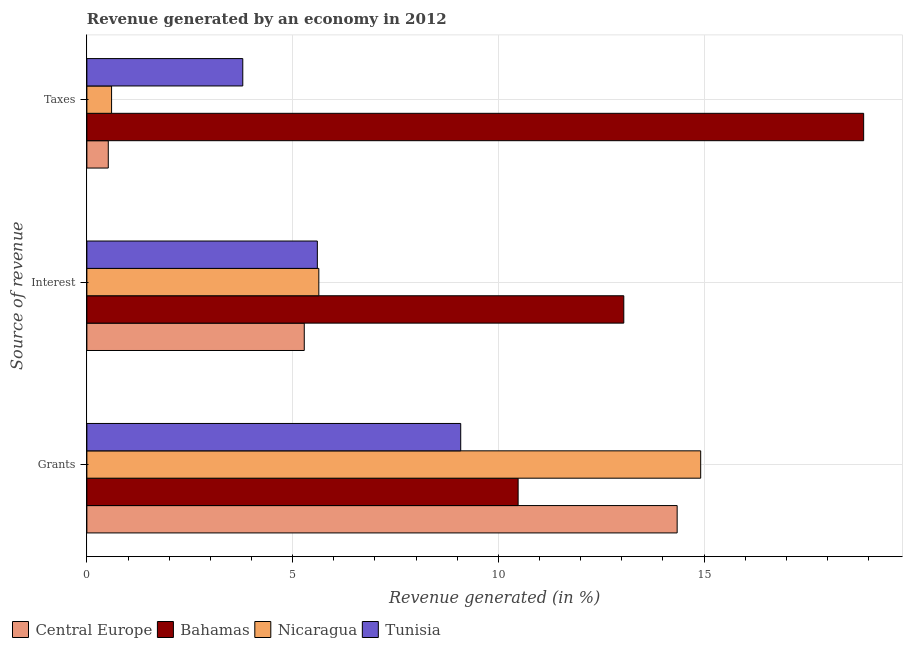How many different coloured bars are there?
Provide a short and direct response. 4. How many groups of bars are there?
Your answer should be very brief. 3. Are the number of bars per tick equal to the number of legend labels?
Offer a very short reply. Yes. How many bars are there on the 3rd tick from the bottom?
Ensure brevity in your answer.  4. What is the label of the 3rd group of bars from the top?
Provide a succinct answer. Grants. What is the percentage of revenue generated by taxes in Bahamas?
Ensure brevity in your answer.  18.88. Across all countries, what is the maximum percentage of revenue generated by grants?
Provide a succinct answer. 14.92. Across all countries, what is the minimum percentage of revenue generated by interest?
Ensure brevity in your answer.  5.28. In which country was the percentage of revenue generated by taxes maximum?
Give a very brief answer. Bahamas. In which country was the percentage of revenue generated by taxes minimum?
Ensure brevity in your answer.  Central Europe. What is the total percentage of revenue generated by interest in the graph?
Offer a very short reply. 29.57. What is the difference between the percentage of revenue generated by grants in Bahamas and that in Nicaragua?
Offer a very short reply. -4.44. What is the difference between the percentage of revenue generated by interest in Tunisia and the percentage of revenue generated by grants in Nicaragua?
Provide a succinct answer. -9.32. What is the average percentage of revenue generated by taxes per country?
Offer a terse response. 5.95. What is the difference between the percentage of revenue generated by interest and percentage of revenue generated by taxes in Central Europe?
Offer a very short reply. 4.76. What is the ratio of the percentage of revenue generated by grants in Nicaragua to that in Tunisia?
Offer a very short reply. 1.64. Is the percentage of revenue generated by taxes in Bahamas less than that in Central Europe?
Give a very brief answer. No. What is the difference between the highest and the second highest percentage of revenue generated by taxes?
Provide a succinct answer. 15.09. What is the difference between the highest and the lowest percentage of revenue generated by taxes?
Make the answer very short. 18.36. In how many countries, is the percentage of revenue generated by grants greater than the average percentage of revenue generated by grants taken over all countries?
Offer a very short reply. 2. What does the 3rd bar from the top in Interest represents?
Your response must be concise. Bahamas. What does the 2nd bar from the bottom in Taxes represents?
Your answer should be very brief. Bahamas. Is it the case that in every country, the sum of the percentage of revenue generated by grants and percentage of revenue generated by interest is greater than the percentage of revenue generated by taxes?
Keep it short and to the point. Yes. Are all the bars in the graph horizontal?
Your answer should be very brief. Yes. How many countries are there in the graph?
Give a very brief answer. 4. How many legend labels are there?
Ensure brevity in your answer.  4. What is the title of the graph?
Keep it short and to the point. Revenue generated by an economy in 2012. What is the label or title of the X-axis?
Provide a short and direct response. Revenue generated (in %). What is the label or title of the Y-axis?
Keep it short and to the point. Source of revenue. What is the Revenue generated (in %) in Central Europe in Grants?
Your answer should be compact. 14.35. What is the Revenue generated (in %) of Bahamas in Grants?
Keep it short and to the point. 10.48. What is the Revenue generated (in %) of Nicaragua in Grants?
Your response must be concise. 14.92. What is the Revenue generated (in %) of Tunisia in Grants?
Provide a short and direct response. 9.09. What is the Revenue generated (in %) in Central Europe in Interest?
Ensure brevity in your answer.  5.28. What is the Revenue generated (in %) in Bahamas in Interest?
Your response must be concise. 13.05. What is the Revenue generated (in %) in Nicaragua in Interest?
Ensure brevity in your answer.  5.64. What is the Revenue generated (in %) of Tunisia in Interest?
Provide a short and direct response. 5.6. What is the Revenue generated (in %) of Central Europe in Taxes?
Offer a very short reply. 0.52. What is the Revenue generated (in %) of Bahamas in Taxes?
Give a very brief answer. 18.88. What is the Revenue generated (in %) in Nicaragua in Taxes?
Give a very brief answer. 0.6. What is the Revenue generated (in %) of Tunisia in Taxes?
Your response must be concise. 3.79. Across all Source of revenue, what is the maximum Revenue generated (in %) of Central Europe?
Make the answer very short. 14.35. Across all Source of revenue, what is the maximum Revenue generated (in %) of Bahamas?
Provide a succinct answer. 18.88. Across all Source of revenue, what is the maximum Revenue generated (in %) of Nicaragua?
Your answer should be compact. 14.92. Across all Source of revenue, what is the maximum Revenue generated (in %) in Tunisia?
Provide a succinct answer. 9.09. Across all Source of revenue, what is the minimum Revenue generated (in %) in Central Europe?
Your response must be concise. 0.52. Across all Source of revenue, what is the minimum Revenue generated (in %) of Bahamas?
Provide a succinct answer. 10.48. Across all Source of revenue, what is the minimum Revenue generated (in %) of Nicaragua?
Provide a succinct answer. 0.6. Across all Source of revenue, what is the minimum Revenue generated (in %) in Tunisia?
Give a very brief answer. 3.79. What is the total Revenue generated (in %) in Central Europe in the graph?
Give a very brief answer. 20.15. What is the total Revenue generated (in %) of Bahamas in the graph?
Your answer should be very brief. 42.41. What is the total Revenue generated (in %) of Nicaragua in the graph?
Make the answer very short. 21.16. What is the total Revenue generated (in %) in Tunisia in the graph?
Your response must be concise. 18.48. What is the difference between the Revenue generated (in %) in Central Europe in Grants and that in Interest?
Make the answer very short. 9.06. What is the difference between the Revenue generated (in %) in Bahamas in Grants and that in Interest?
Your answer should be very brief. -2.57. What is the difference between the Revenue generated (in %) in Nicaragua in Grants and that in Interest?
Offer a terse response. 9.28. What is the difference between the Revenue generated (in %) of Tunisia in Grants and that in Interest?
Your answer should be compact. 3.48. What is the difference between the Revenue generated (in %) in Central Europe in Grants and that in Taxes?
Your answer should be very brief. 13.83. What is the difference between the Revenue generated (in %) of Bahamas in Grants and that in Taxes?
Your answer should be very brief. -8.4. What is the difference between the Revenue generated (in %) in Nicaragua in Grants and that in Taxes?
Ensure brevity in your answer.  14.32. What is the difference between the Revenue generated (in %) of Tunisia in Grants and that in Taxes?
Provide a short and direct response. 5.3. What is the difference between the Revenue generated (in %) of Central Europe in Interest and that in Taxes?
Offer a terse response. 4.76. What is the difference between the Revenue generated (in %) in Bahamas in Interest and that in Taxes?
Give a very brief answer. -5.83. What is the difference between the Revenue generated (in %) in Nicaragua in Interest and that in Taxes?
Offer a terse response. 5.04. What is the difference between the Revenue generated (in %) of Tunisia in Interest and that in Taxes?
Offer a terse response. 1.81. What is the difference between the Revenue generated (in %) in Central Europe in Grants and the Revenue generated (in %) in Bahamas in Interest?
Keep it short and to the point. 1.3. What is the difference between the Revenue generated (in %) of Central Europe in Grants and the Revenue generated (in %) of Nicaragua in Interest?
Make the answer very short. 8.71. What is the difference between the Revenue generated (in %) in Central Europe in Grants and the Revenue generated (in %) in Tunisia in Interest?
Ensure brevity in your answer.  8.74. What is the difference between the Revenue generated (in %) in Bahamas in Grants and the Revenue generated (in %) in Nicaragua in Interest?
Provide a succinct answer. 4.84. What is the difference between the Revenue generated (in %) of Bahamas in Grants and the Revenue generated (in %) of Tunisia in Interest?
Offer a very short reply. 4.88. What is the difference between the Revenue generated (in %) of Nicaragua in Grants and the Revenue generated (in %) of Tunisia in Interest?
Provide a short and direct response. 9.32. What is the difference between the Revenue generated (in %) in Central Europe in Grants and the Revenue generated (in %) in Bahamas in Taxes?
Offer a terse response. -4.53. What is the difference between the Revenue generated (in %) of Central Europe in Grants and the Revenue generated (in %) of Nicaragua in Taxes?
Offer a terse response. 13.75. What is the difference between the Revenue generated (in %) in Central Europe in Grants and the Revenue generated (in %) in Tunisia in Taxes?
Provide a succinct answer. 10.56. What is the difference between the Revenue generated (in %) of Bahamas in Grants and the Revenue generated (in %) of Nicaragua in Taxes?
Your answer should be compact. 9.88. What is the difference between the Revenue generated (in %) of Bahamas in Grants and the Revenue generated (in %) of Tunisia in Taxes?
Offer a very short reply. 6.69. What is the difference between the Revenue generated (in %) of Nicaragua in Grants and the Revenue generated (in %) of Tunisia in Taxes?
Make the answer very short. 11.13. What is the difference between the Revenue generated (in %) in Central Europe in Interest and the Revenue generated (in %) in Bahamas in Taxes?
Keep it short and to the point. -13.6. What is the difference between the Revenue generated (in %) in Central Europe in Interest and the Revenue generated (in %) in Nicaragua in Taxes?
Give a very brief answer. 4.68. What is the difference between the Revenue generated (in %) in Central Europe in Interest and the Revenue generated (in %) in Tunisia in Taxes?
Offer a terse response. 1.49. What is the difference between the Revenue generated (in %) of Bahamas in Interest and the Revenue generated (in %) of Nicaragua in Taxes?
Your response must be concise. 12.45. What is the difference between the Revenue generated (in %) of Bahamas in Interest and the Revenue generated (in %) of Tunisia in Taxes?
Keep it short and to the point. 9.26. What is the difference between the Revenue generated (in %) of Nicaragua in Interest and the Revenue generated (in %) of Tunisia in Taxes?
Your response must be concise. 1.85. What is the average Revenue generated (in %) in Central Europe per Source of revenue?
Ensure brevity in your answer.  6.72. What is the average Revenue generated (in %) in Bahamas per Source of revenue?
Give a very brief answer. 14.14. What is the average Revenue generated (in %) of Nicaragua per Source of revenue?
Provide a short and direct response. 7.05. What is the average Revenue generated (in %) of Tunisia per Source of revenue?
Keep it short and to the point. 6.16. What is the difference between the Revenue generated (in %) of Central Europe and Revenue generated (in %) of Bahamas in Grants?
Your answer should be compact. 3.87. What is the difference between the Revenue generated (in %) of Central Europe and Revenue generated (in %) of Nicaragua in Grants?
Make the answer very short. -0.57. What is the difference between the Revenue generated (in %) of Central Europe and Revenue generated (in %) of Tunisia in Grants?
Your answer should be very brief. 5.26. What is the difference between the Revenue generated (in %) of Bahamas and Revenue generated (in %) of Nicaragua in Grants?
Give a very brief answer. -4.44. What is the difference between the Revenue generated (in %) of Bahamas and Revenue generated (in %) of Tunisia in Grants?
Offer a very short reply. 1.4. What is the difference between the Revenue generated (in %) of Nicaragua and Revenue generated (in %) of Tunisia in Grants?
Provide a succinct answer. 5.83. What is the difference between the Revenue generated (in %) of Central Europe and Revenue generated (in %) of Bahamas in Interest?
Your answer should be compact. -7.77. What is the difference between the Revenue generated (in %) of Central Europe and Revenue generated (in %) of Nicaragua in Interest?
Offer a very short reply. -0.35. What is the difference between the Revenue generated (in %) of Central Europe and Revenue generated (in %) of Tunisia in Interest?
Provide a short and direct response. -0.32. What is the difference between the Revenue generated (in %) in Bahamas and Revenue generated (in %) in Nicaragua in Interest?
Provide a short and direct response. 7.41. What is the difference between the Revenue generated (in %) of Bahamas and Revenue generated (in %) of Tunisia in Interest?
Keep it short and to the point. 7.45. What is the difference between the Revenue generated (in %) in Nicaragua and Revenue generated (in %) in Tunisia in Interest?
Provide a short and direct response. 0.04. What is the difference between the Revenue generated (in %) in Central Europe and Revenue generated (in %) in Bahamas in Taxes?
Keep it short and to the point. -18.36. What is the difference between the Revenue generated (in %) of Central Europe and Revenue generated (in %) of Nicaragua in Taxes?
Offer a terse response. -0.08. What is the difference between the Revenue generated (in %) of Central Europe and Revenue generated (in %) of Tunisia in Taxes?
Offer a terse response. -3.27. What is the difference between the Revenue generated (in %) in Bahamas and Revenue generated (in %) in Nicaragua in Taxes?
Offer a terse response. 18.28. What is the difference between the Revenue generated (in %) of Bahamas and Revenue generated (in %) of Tunisia in Taxes?
Provide a short and direct response. 15.09. What is the difference between the Revenue generated (in %) of Nicaragua and Revenue generated (in %) of Tunisia in Taxes?
Offer a very short reply. -3.19. What is the ratio of the Revenue generated (in %) of Central Europe in Grants to that in Interest?
Provide a succinct answer. 2.72. What is the ratio of the Revenue generated (in %) in Bahamas in Grants to that in Interest?
Your answer should be very brief. 0.8. What is the ratio of the Revenue generated (in %) in Nicaragua in Grants to that in Interest?
Provide a short and direct response. 2.65. What is the ratio of the Revenue generated (in %) of Tunisia in Grants to that in Interest?
Offer a very short reply. 1.62. What is the ratio of the Revenue generated (in %) of Central Europe in Grants to that in Taxes?
Ensure brevity in your answer.  27.58. What is the ratio of the Revenue generated (in %) of Bahamas in Grants to that in Taxes?
Provide a short and direct response. 0.56. What is the ratio of the Revenue generated (in %) in Nicaragua in Grants to that in Taxes?
Provide a short and direct response. 24.85. What is the ratio of the Revenue generated (in %) in Tunisia in Grants to that in Taxes?
Your answer should be compact. 2.4. What is the ratio of the Revenue generated (in %) of Central Europe in Interest to that in Taxes?
Your answer should be compact. 10.16. What is the ratio of the Revenue generated (in %) of Bahamas in Interest to that in Taxes?
Offer a terse response. 0.69. What is the ratio of the Revenue generated (in %) in Nicaragua in Interest to that in Taxes?
Your answer should be very brief. 9.39. What is the ratio of the Revenue generated (in %) in Tunisia in Interest to that in Taxes?
Make the answer very short. 1.48. What is the difference between the highest and the second highest Revenue generated (in %) in Central Europe?
Ensure brevity in your answer.  9.06. What is the difference between the highest and the second highest Revenue generated (in %) in Bahamas?
Your answer should be very brief. 5.83. What is the difference between the highest and the second highest Revenue generated (in %) of Nicaragua?
Your answer should be compact. 9.28. What is the difference between the highest and the second highest Revenue generated (in %) in Tunisia?
Offer a very short reply. 3.48. What is the difference between the highest and the lowest Revenue generated (in %) of Central Europe?
Provide a short and direct response. 13.83. What is the difference between the highest and the lowest Revenue generated (in %) in Bahamas?
Your response must be concise. 8.4. What is the difference between the highest and the lowest Revenue generated (in %) of Nicaragua?
Your answer should be compact. 14.32. What is the difference between the highest and the lowest Revenue generated (in %) of Tunisia?
Your answer should be very brief. 5.3. 